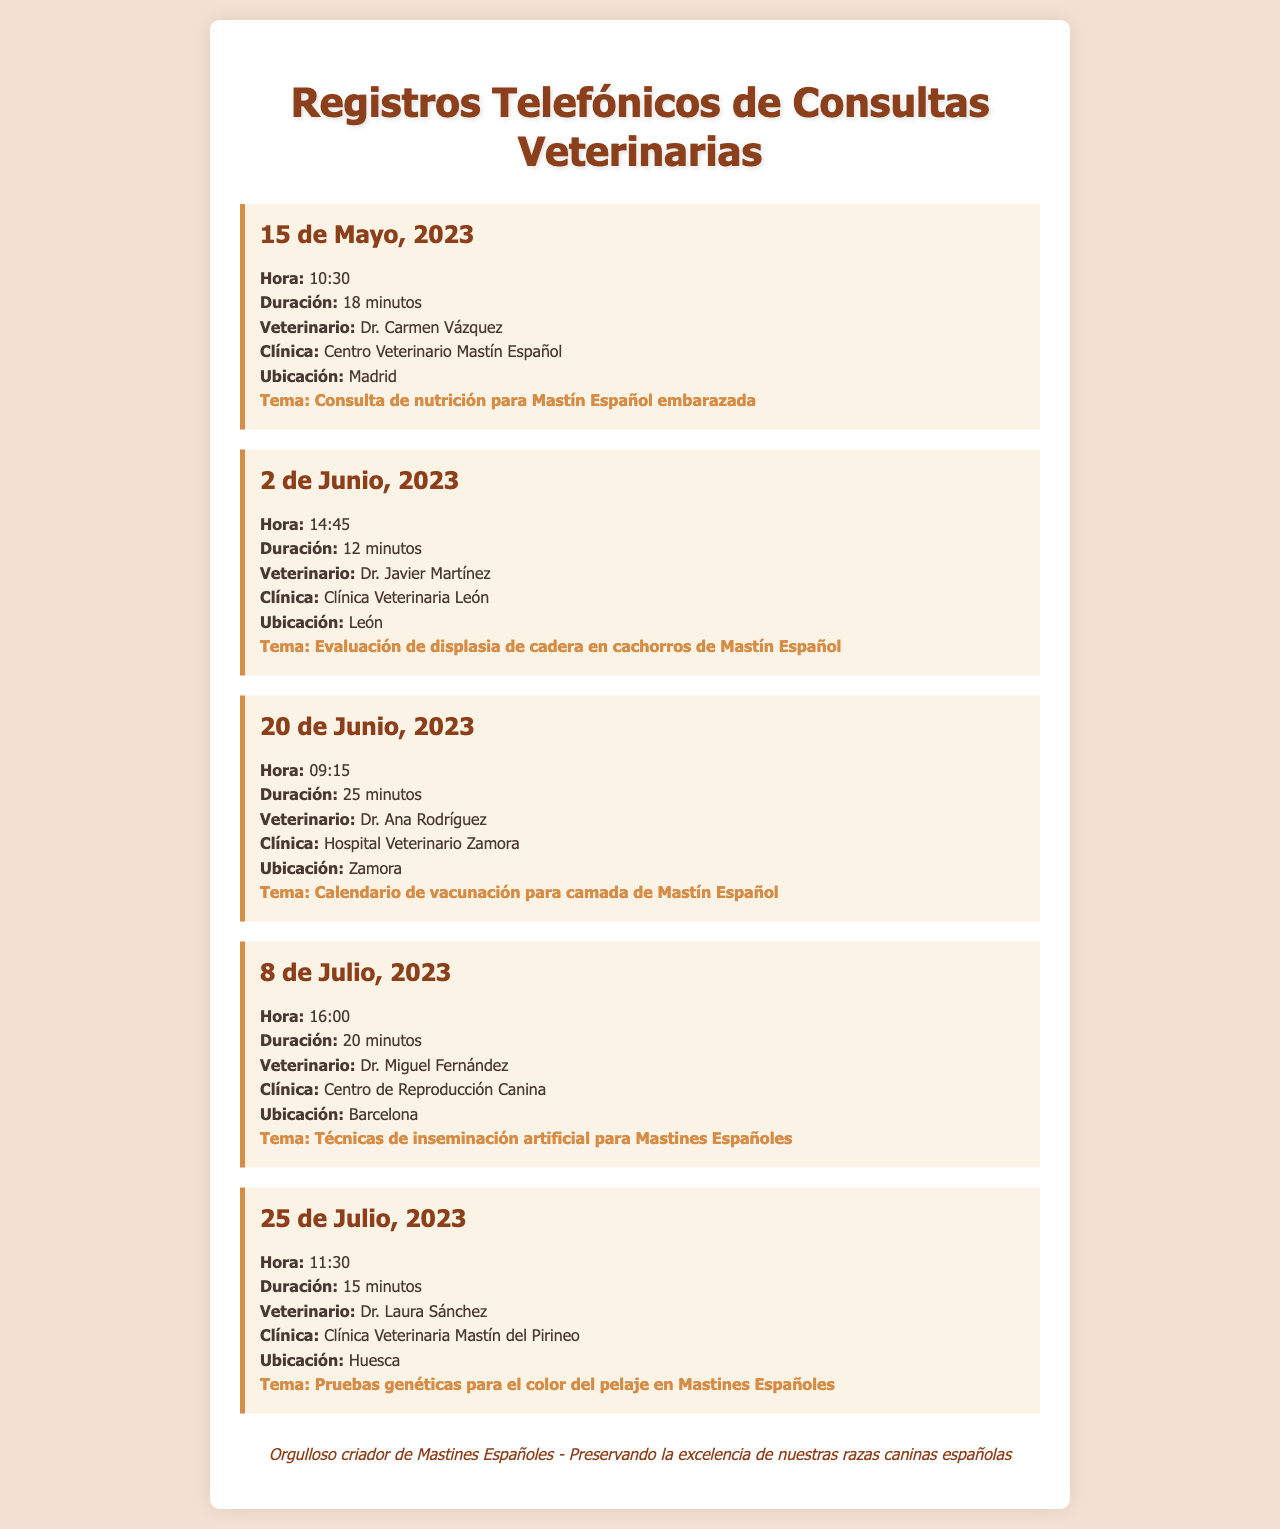¿Quién fue el veterinario en la primera consulta? La primera consulta fue atendida por la Dr. Carmen Vázquez.
Answer: Dr. Carmen Vázquez ¿Cuál fue la duración de la consulta del 2 de Junio, 2023? La consulta del 2 de Junio, 2023, tuvo una duración de 12 minutos.
Answer: 12 minutos ¿Qué tipo de evaluación se realizó el 2 de Junio, 2023? En esta consulta se realizó una evaluación de displasia de cadera.
Answer: Evaluación de displasia de cadera ¿Cuántos minutos duró la consulta sobre el calendario de vacunación? La consulta sobre el calendario de vacunación duró 25 minutos.
Answer: 25 minutos ¿Cuál es la ubicación de la Clínica Veterinaria León? La Clínica Veterinaria León está ubicada en León.
Answer: León ¿Qué tema se trató en la consulta del 8 de Julio, 2023? En la consulta se trataron las técnicas de inseminación artificial.
Answer: Técnicas de inseminación artificial ¿Cuándo se realizó la consulta sobre las pruebas genéticas para el color del pelaje? La consulta sobre las pruebas genéticas se realizó el 25 de Julio, 2023.
Answer: 25 de Julio, 2023 ¿Cuál es el nombre de la clínica donde trabaja el Dr. Miguel Fernández? El Dr. Miguel Fernández trabaja en el Centro de Reproducción Canina.
Answer: Centro de Reproducción Canina ¿Qué fechas de consulta se mencionan en el documento? Las fechas de consulta son 15 de Mayo, 2 de Junio, 20 de Junio, 8 de Julio y 25 de Julio.
Answer: 15 de Mayo, 2 de Junio, 20 de Junio, 8 de Julio, 25 de Julio 